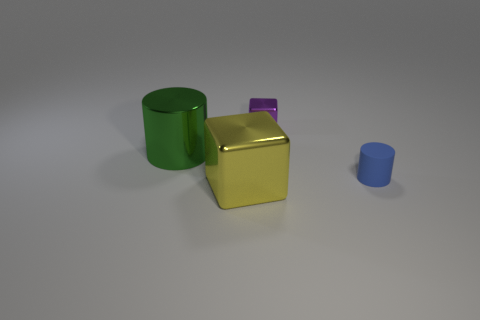Add 4 large green cylinders. How many objects exist? 8 Subtract 1 cylinders. How many cylinders are left? 1 Subtract all red blocks. Subtract all brown cylinders. How many blocks are left? 2 Subtract 0 green balls. How many objects are left? 4 Subtract all green cylinders. How many green cubes are left? 0 Subtract all small purple metallic things. Subtract all small purple cylinders. How many objects are left? 3 Add 3 yellow cubes. How many yellow cubes are left? 4 Add 4 cubes. How many cubes exist? 6 